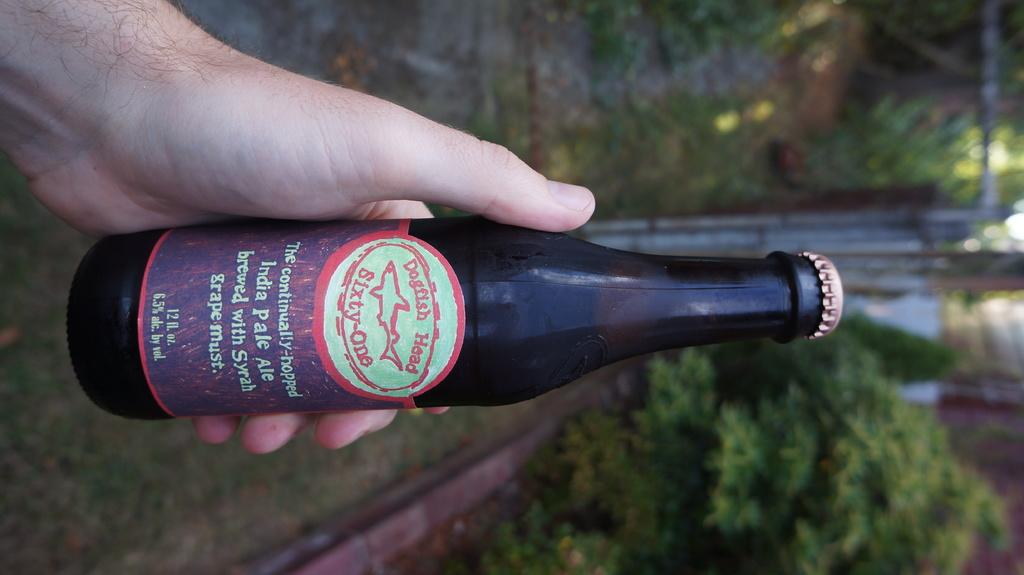<image>
Write a terse but informative summary of the picture. The beer bottle has Dogfish Heed on the logo 